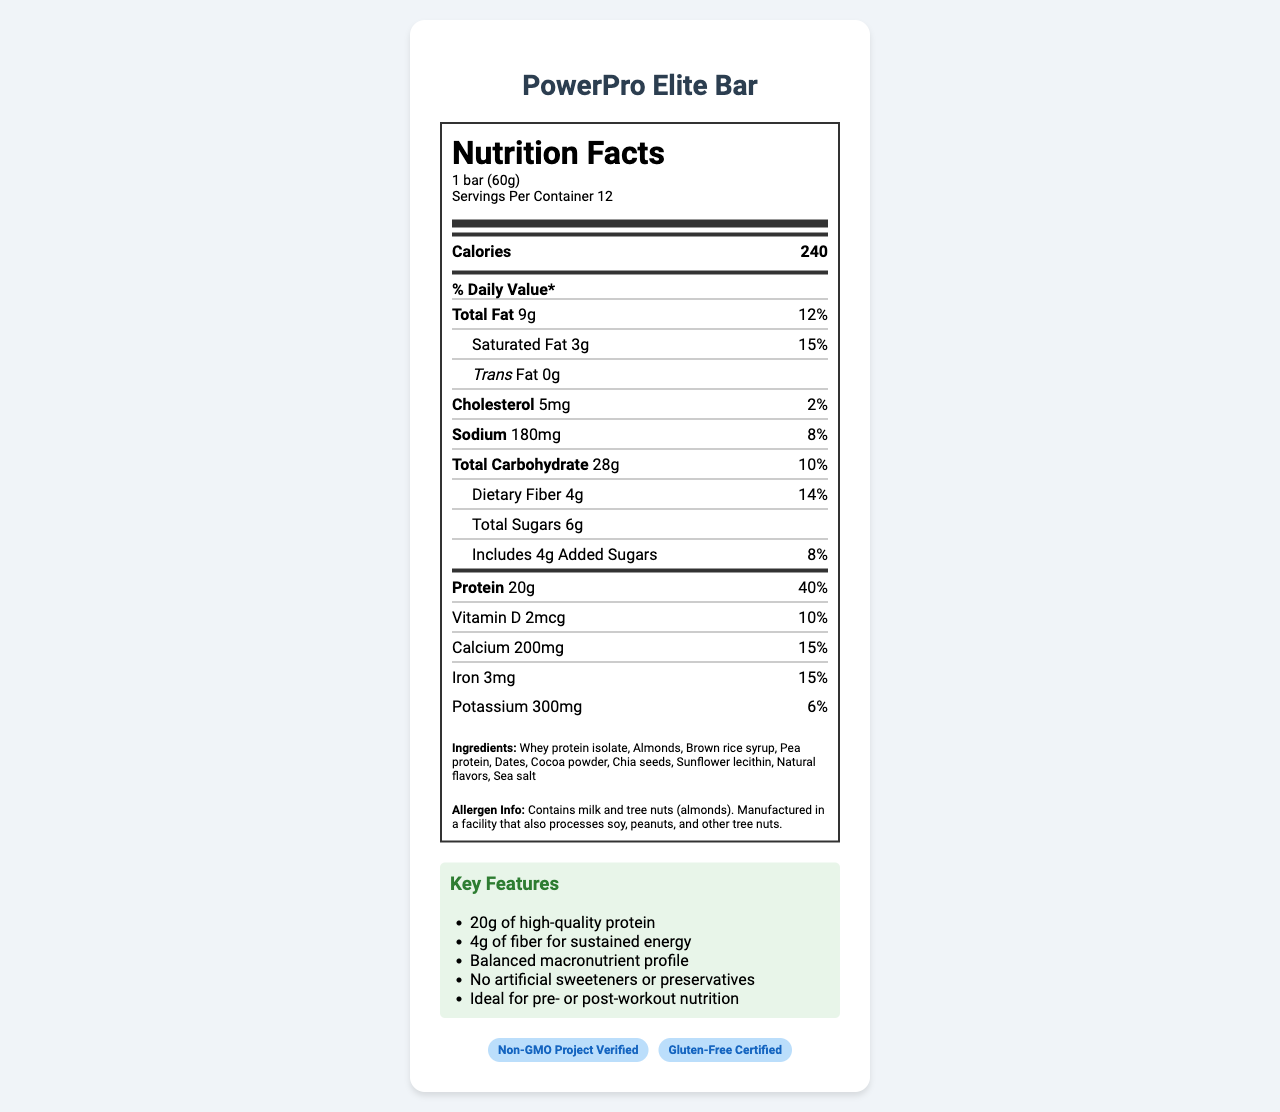what is the serving size of the PowerPro Elite Bar? The serving size is listed under the nutrition label header as "1 bar (60g)".
Answer: 1 bar (60g) how many grams of protein are in one serving of the PowerPro Elite Bar? Under the nutrient details, the protein amount is listed as "20g".
Answer: 20g how many total grams of fat does one serving contain? The total fat content is shown as "9g" in the nutrition label.
Answer: 9g what is the daily value percentage for calcium? The daily value for calcium is indicated as "15%" in the nutrient breakdown section.
Answer: 15% how much sodium is in one bar? The sodium content per bar is listed under nutrients as "180mg".
Answer: 180mg What certifications does the PowerPro Elite Bar have? A. USDA Organic B. Non-GMO Project Verified C. Gluten-Free Certified D. Fair Trade Certified The bar is certified as "Non-GMO Project Verified" and "Gluten-Free Certified" according to the certifications section.
Answer: B, C What is the primary target audience for the PowerPro Elite Bar? A. Kids B. Seniors C. Busy executives D. Athletes The target audience is specified as "Active professionals, project managers, and busy executives".
Answer: C Does the PowerPro Elite Bar contain any dietary fiber? The nutrition label mentions that the bar contains "4g" of dietary fiber.
Answer: Yes Is the PowerPro Elite Bar made with artificial sweeteners? The key features section explicitly mentions "No artificial sweeteners or preservatives".
Answer: No Summarize the key features and nutritional benefits of the PowerPro Elite Bar. The summary provides an overview of the bar's key features and nutritional benefits mentioned in the document, including the protein content, fiber content, certifications, and the lack of artificial sweeteners or preservatives.
Answer: The PowerPro Elite Bar is a high-protein snack designed for active professionals, containing 20g of protein, 4g of dietary fiber, and a balanced nutrient profile. It is certified Non-GMO and Gluten-Free, contains no artificial sweeteners or preservatives, and is ideal for pre- or post-workout nutrition. Who manufactures the PowerPro Elite Bar? The manufacturer's name is listed at the bottom of the document.
Answer: NutriTech Solutions Inc. Can the exact date of production for the PowerPro Elite Bar be determined from the label? The document does not provide any details regarding the production date of the product.
Answer: Not enough information 